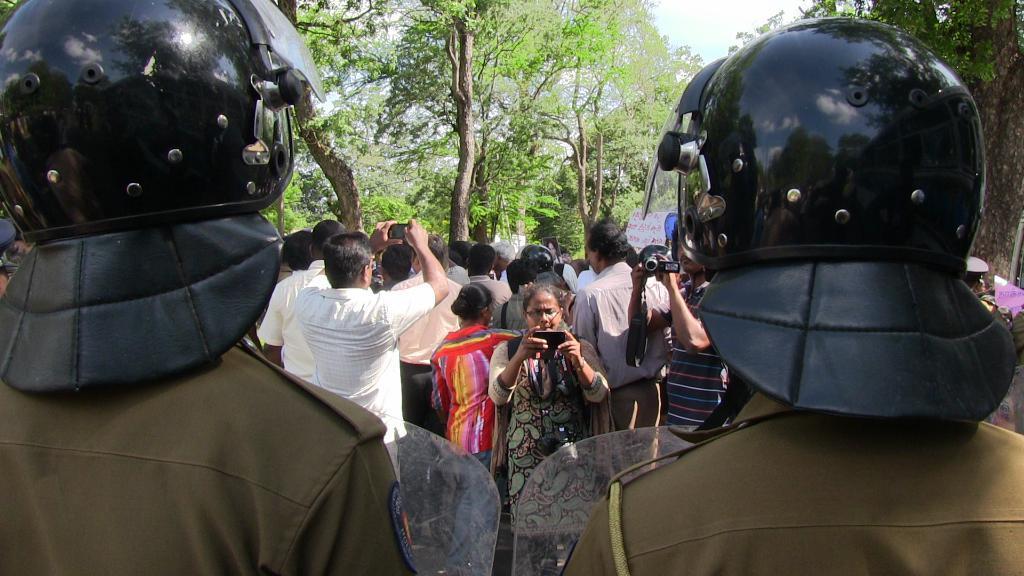Can you describe this image briefly? There are two persons standing at the bottom of this image is wearing a helmets, and there are some persons in the background. There are some trees as we can see at the top of this image. 